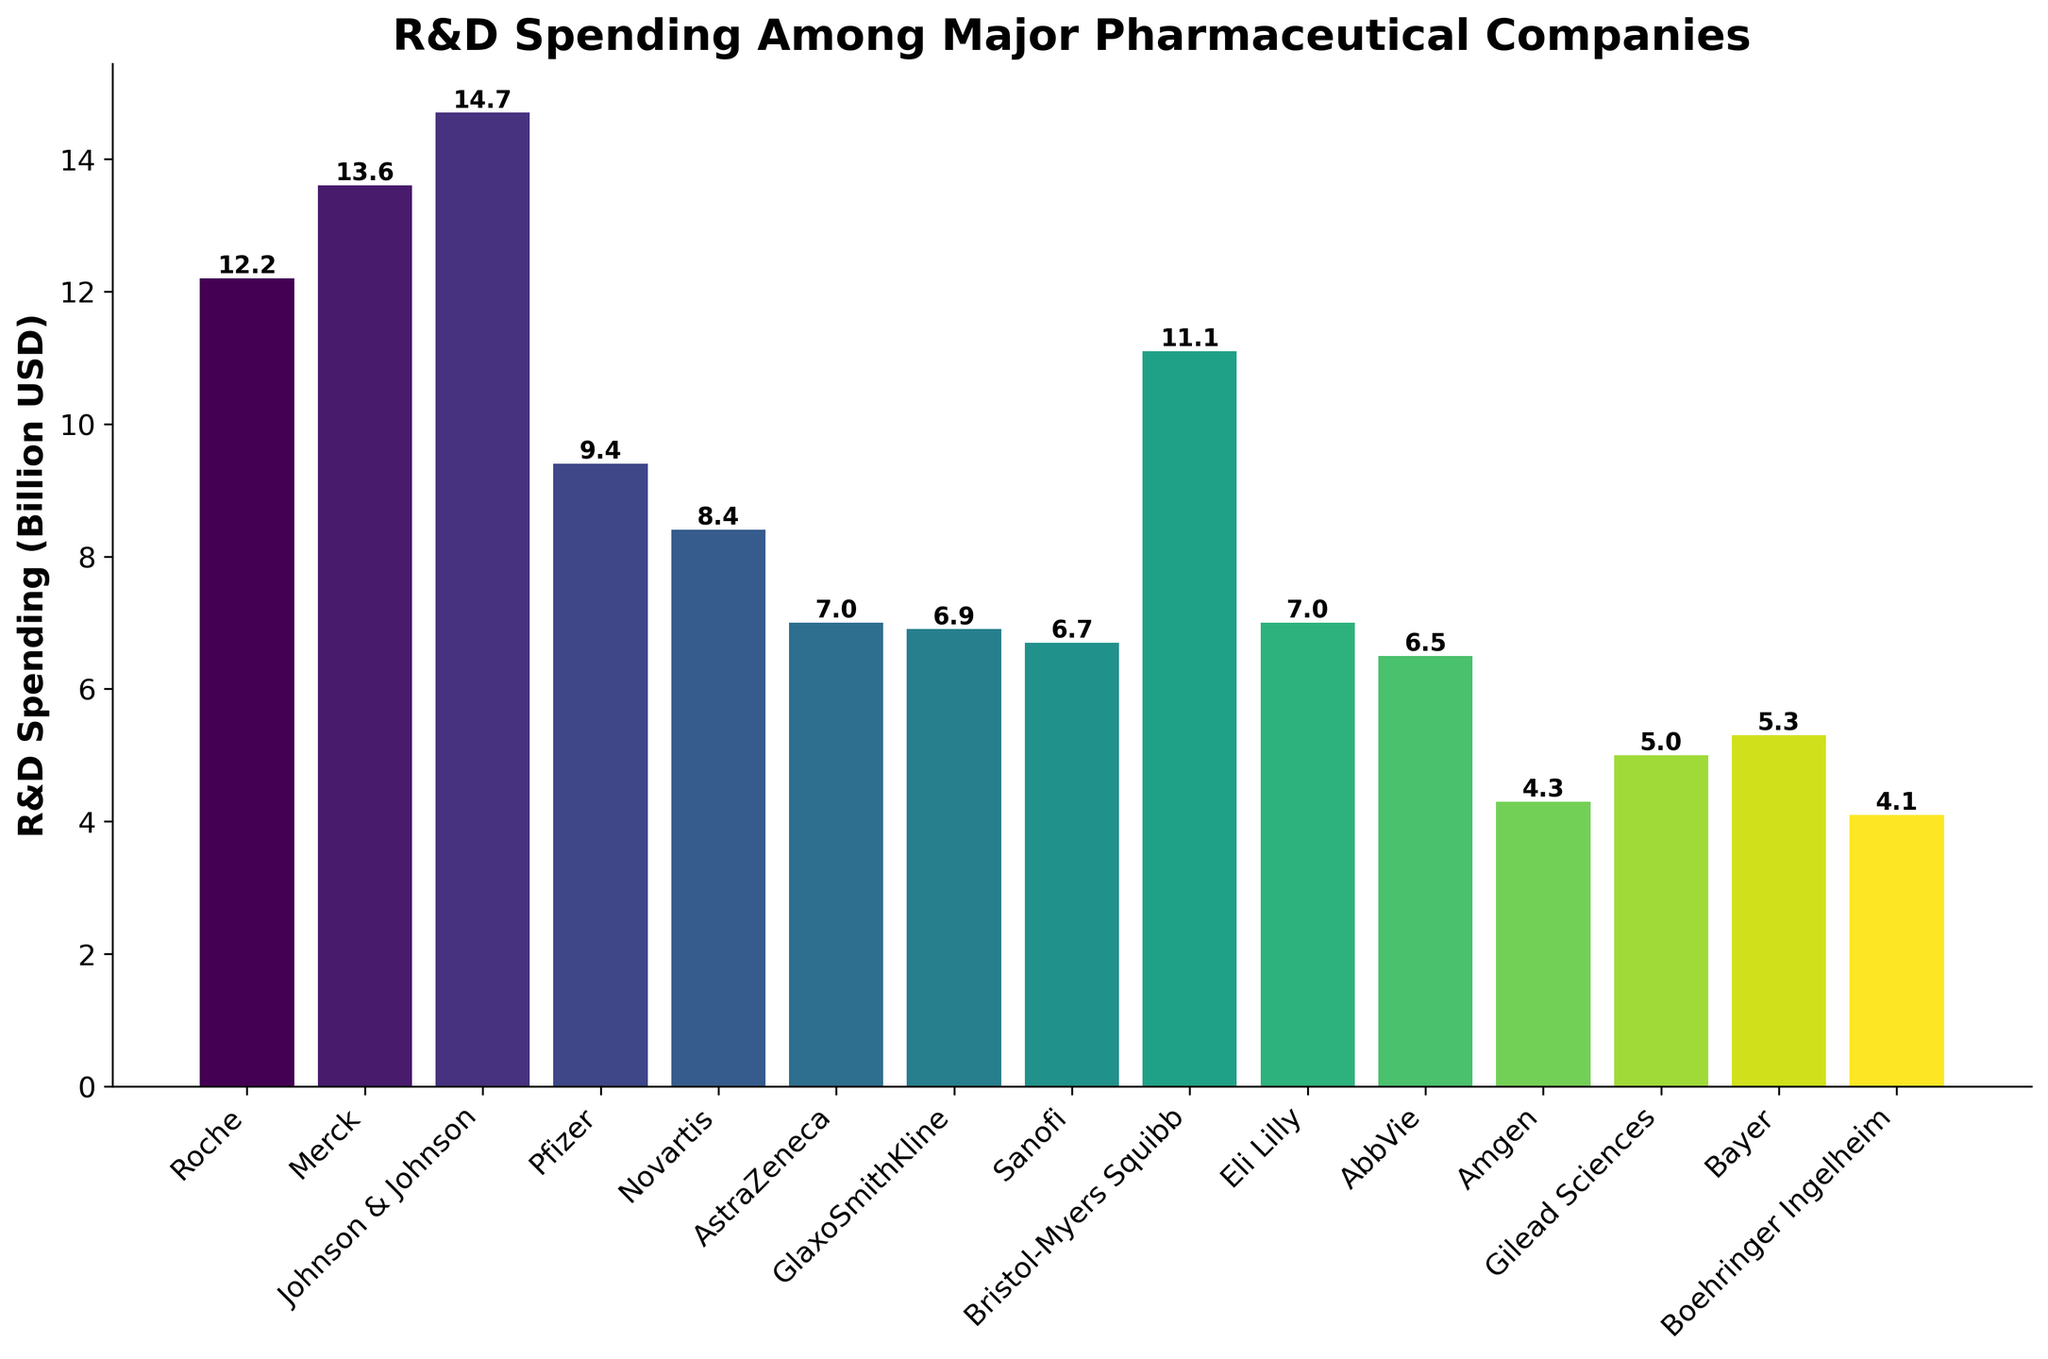Which company has the highest R&D spending? The highest bar on the chart represents Johnson & Johnson, with an R&D spending of $14.7 billion.
Answer: Johnson & Johnson Which company has the lowest R&D spending? The lowest bar on the chart represents Boehringer Ingelheim, with an R&D spending of $4.1 billion.
Answer: Boehringer Ingelheim What is the difference in R&D spending between Pfizer and Novartis? Pfizer's R&D spending is $9.4 billion, and Novartis's R&D spending is $8.4 billion. The difference is $9.4 billion - $8.4 billion = $1 billion.
Answer: $1 billion Which companies have R&D spending greater than $10 billion? The bars representing companies with R&D spending greater than $10 billion are Johnson & Johnson ($14.7 billion), Merck ($13.6 billion), and Roche ($12.2 billion), as well as Bristol-Myers Squibb ($11.1 billion).
Answer: Johnson & Johnson, Merck, Roche, Bristol-Myers Squibb What is the total R&D spending for Amgen, Gilead Sciences, Bayer, and Boehringer Ingelheim combined? Summing their R&D spending: Amgen ($4.3 billion), Gilead Sciences ($5 billion), Bayer ($5.3 billion), Boehringer Ingelheim ($4.1 billion). Total = $4.3 + $5 + $5.3 + $4.1 = $18.7 billion.
Answer: $18.7 billion What is the average R&D spending across all companies listed? Sum all R&D spending values: $12.2 + $13.6 + $14.7 + $9.4 + $8.4 + $7.0 + $6.9 + $6.7 + $11.1 + $7.0 + $6.5 + $4.3 + $5.0 + $5.3 + $4.1 = $122.2 billion. Divide by the number of companies (15): $122.2 / 15 ≈ $8.15 billion.
Answer: $8.15 billion Rank the companies from highest to lowest R&D spending. The bars can be ordered as follows: Johnson & Johnson ($14.7 billion), Merck ($13.6 billion), Roche ($12.2 billion), Bristol-Myers Squibb ($11.1 billion), Pfizer ($9.4 billion), Novartis ($8.4 billion), Eli Lilly ($7.0 billion), AstraZeneca ($7.0 billion), GlaxoSmithKline ($6.9 billion), Sanofi ($6.7 billion), AbbVie ($6.5 billion), Bayer ($5.3 billion), Gilead Sciences ($5.0 billion), Amgen ($4.3 billion), Boehringer Ingelheim ($4.1 billion).
Answer: Johnson & Johnson, Merck, Roche, Bristol-Myers Squibb, Pfizer, Novartis, Eli Lilly, AstraZeneca, GlaxoSmithKline, Sanofi, AbbVie, Bayer, Gilead Sciences, Amgen, Boehringer Ingelheim Which company has a similar R&D spending to Eli Lilly? Eli Lilly and AstraZeneca both have an R&D spending of $7.0 billion.
Answer: AstraZeneca How much more does Bristol-Myers Squibb spend on R&D compared to Amgen? Bristol-Myers Squibb spends $11.1 billion, and Amgen spends $4.3 billion. The difference is $11.1 billion - $4.3 billion = $6.8 billion.
Answer: $6.8 billion If the combined R&D spending of Sanofi and AbbVie is considered, would it surpass GlaxoSmithKline's R&D spending? Sanofi's R&D spending ($6.7 billion) combined with AbbVie's ($6.5 billion) is $6.7 billion + $6.5 billion = $13.2 billion, which surpasses GlaxoSmithKline's $6.9 billion.
Answer: Yes 